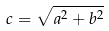Convert formula to latex. <formula><loc_0><loc_0><loc_500><loc_500>c = \sqrt { a ^ { 2 } + b ^ { 2 } }</formula> 